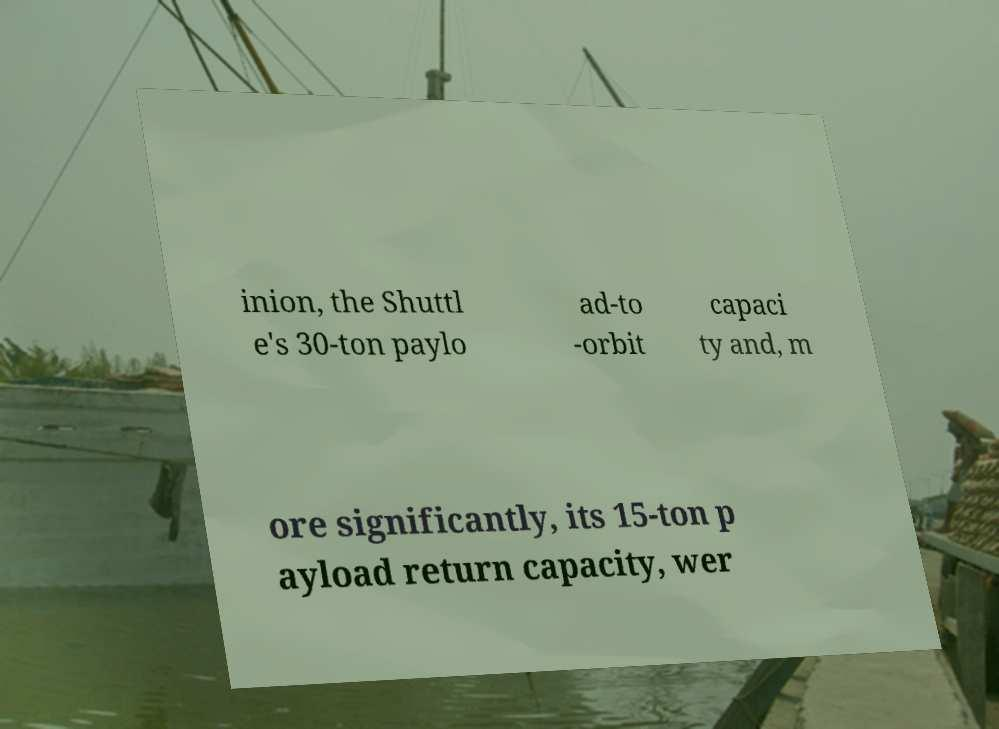Can you accurately transcribe the text from the provided image for me? inion, the Shuttl e's 30-ton paylo ad-to -orbit capaci ty and, m ore significantly, its 15-ton p ayload return capacity, wer 